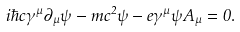<formula> <loc_0><loc_0><loc_500><loc_500>i \hbar { c } \gamma ^ { \mu } \partial _ { \mu } \psi - m c ^ { 2 } \psi - e \gamma ^ { \mu } \psi A _ { \mu } = 0 .</formula> 